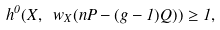<formula> <loc_0><loc_0><loc_500><loc_500>h ^ { 0 } ( X , \ w _ { X } ( n P - ( g - 1 ) Q ) ) \geq 1 ,</formula> 